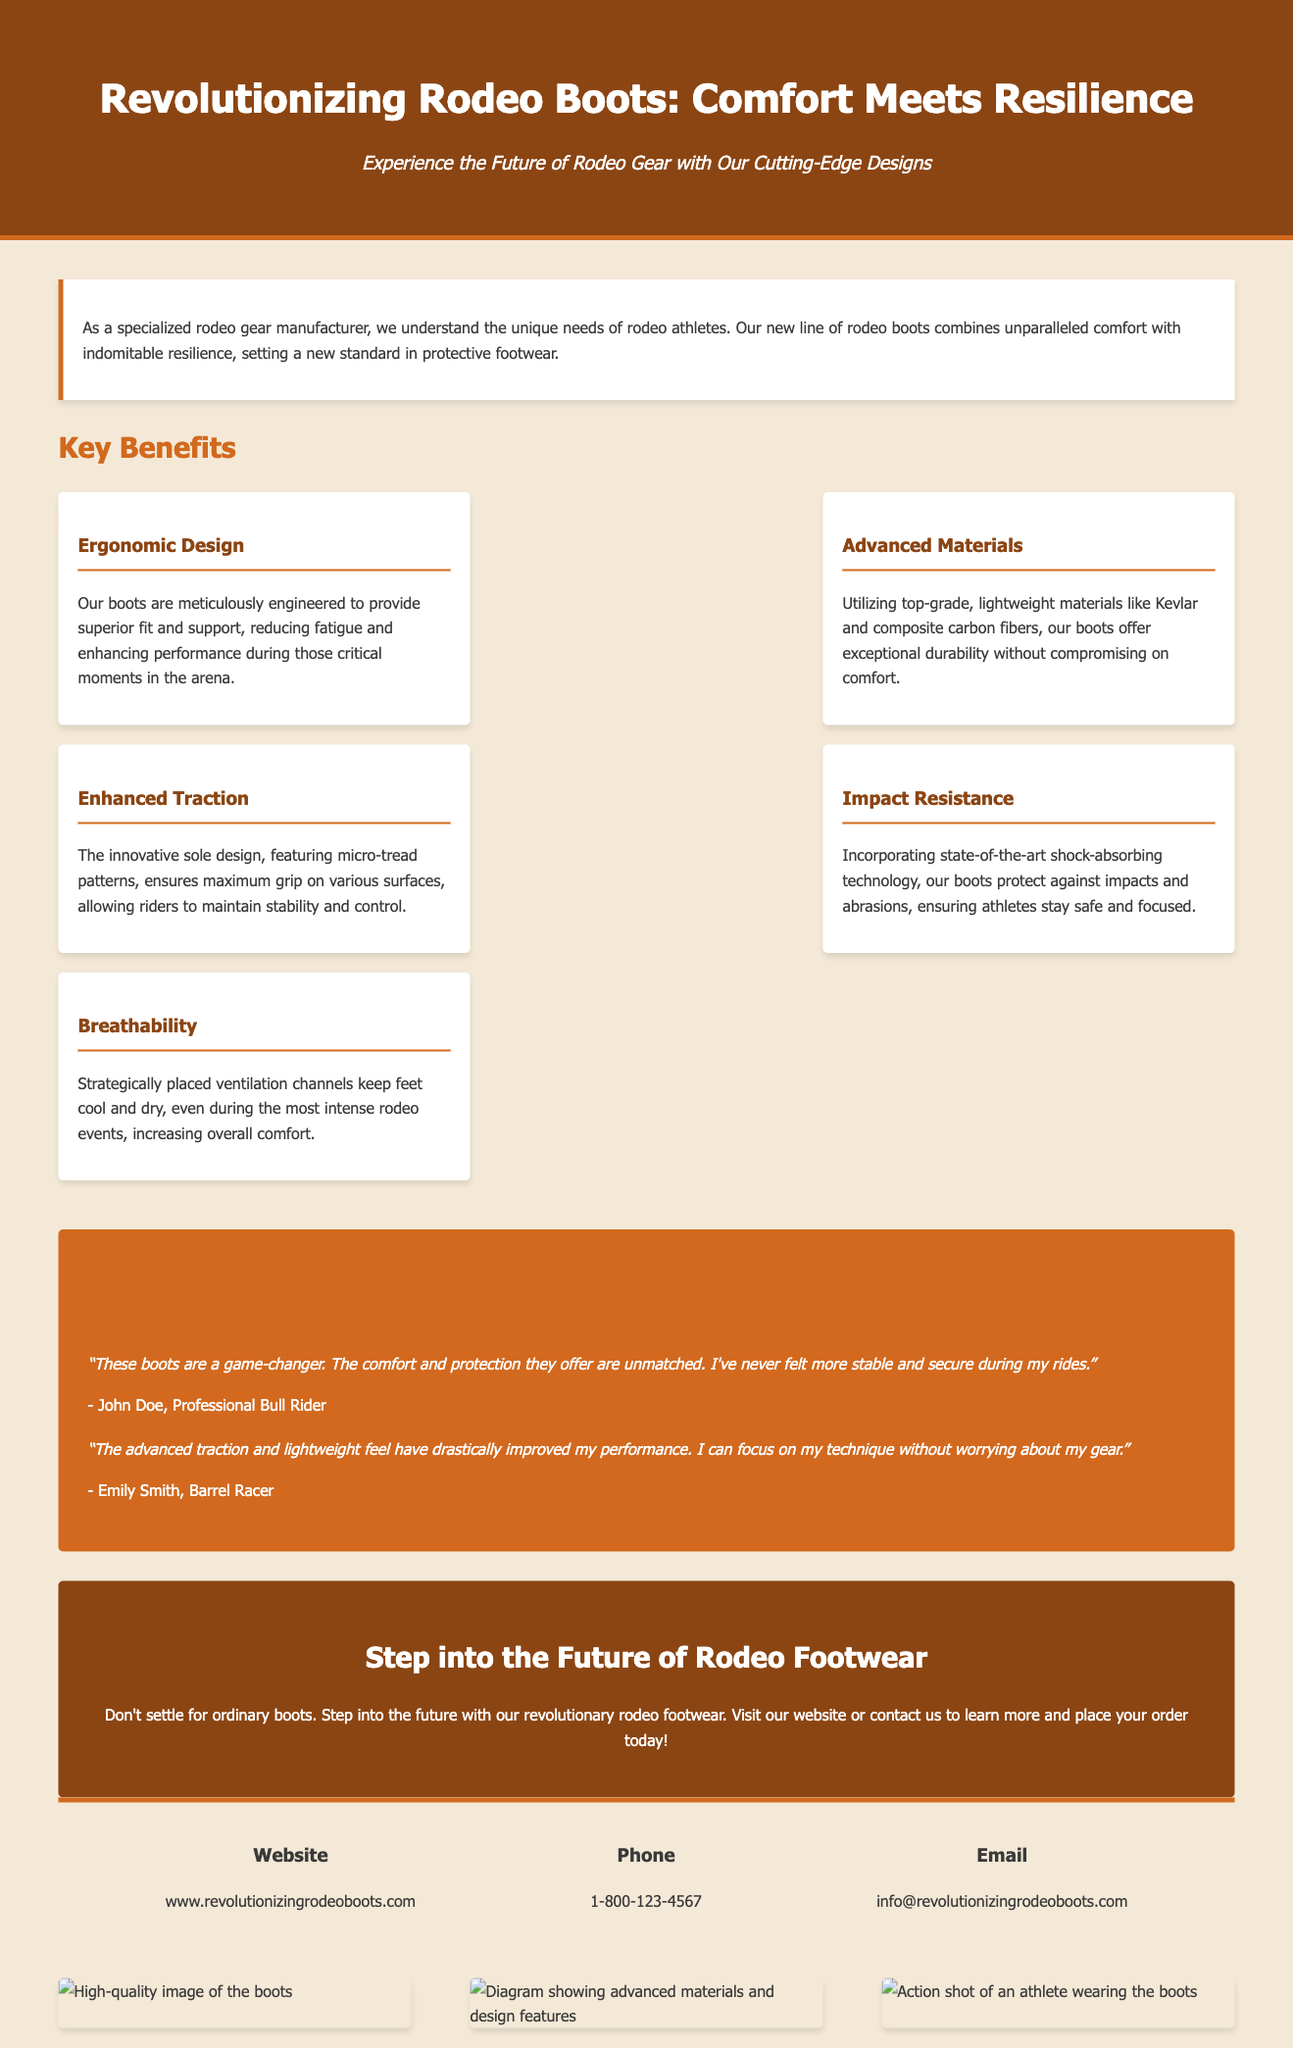what is the title of the advertisement? The title is prominently displayed at the top of the document.
Answer: Revolutionizing Rodeo Boots: Comfort Meets Resilience what material is used in the boots for durability? The document specifies the materials used in the boots.
Answer: Kevlar and composite carbon fibers how many key benefits are listed in the advertisement? The number of key benefits is mentioned in the section heading.
Answer: Five who is quoted in the testimonials section? The testimonials provide names of individuals who experienced the product.
Answer: John Doe and Emily Smith what aspect of the boot design enhances comfort during rodeo events? The document highlights a specific feature that contributes to comfort.
Answer: Breathability what feature of the boots ensures maximum grip? The document mentions a specific design feature related to traction.
Answer: Innovative sole design with micro-tread patterns what is the contact phone number provided? The phone number is included in the contact information section.
Answer: 1-800-123-4567 what does the call-to-action ask potential customers to do? The call-to-action encourages a specific action from potential customers.
Answer: Visit our website or contact us to learn more and place your order today! 